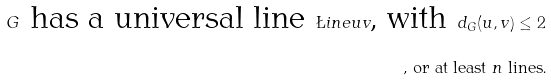<formula> <loc_0><loc_0><loc_500><loc_500>G \text { has a universal line } \L i n e { u v } \text {, with  } d _ { G } ( u , v ) \leq 2 \\ \text {, or at least } n \text { lines.}</formula> 